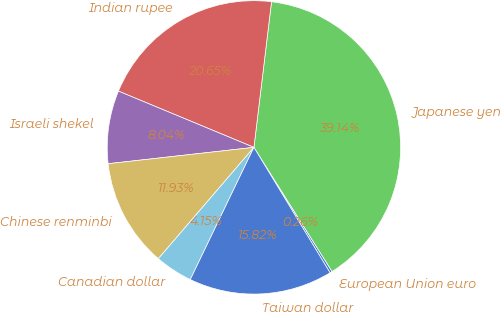Convert chart to OTSL. <chart><loc_0><loc_0><loc_500><loc_500><pie_chart><fcel>European Union euro<fcel>Japanese yen<fcel>Indian rupee<fcel>Israeli shekel<fcel>Chinese renminbi<fcel>Canadian dollar<fcel>Taiwan dollar<nl><fcel>0.26%<fcel>39.14%<fcel>20.65%<fcel>8.04%<fcel>11.93%<fcel>4.15%<fcel>15.82%<nl></chart> 